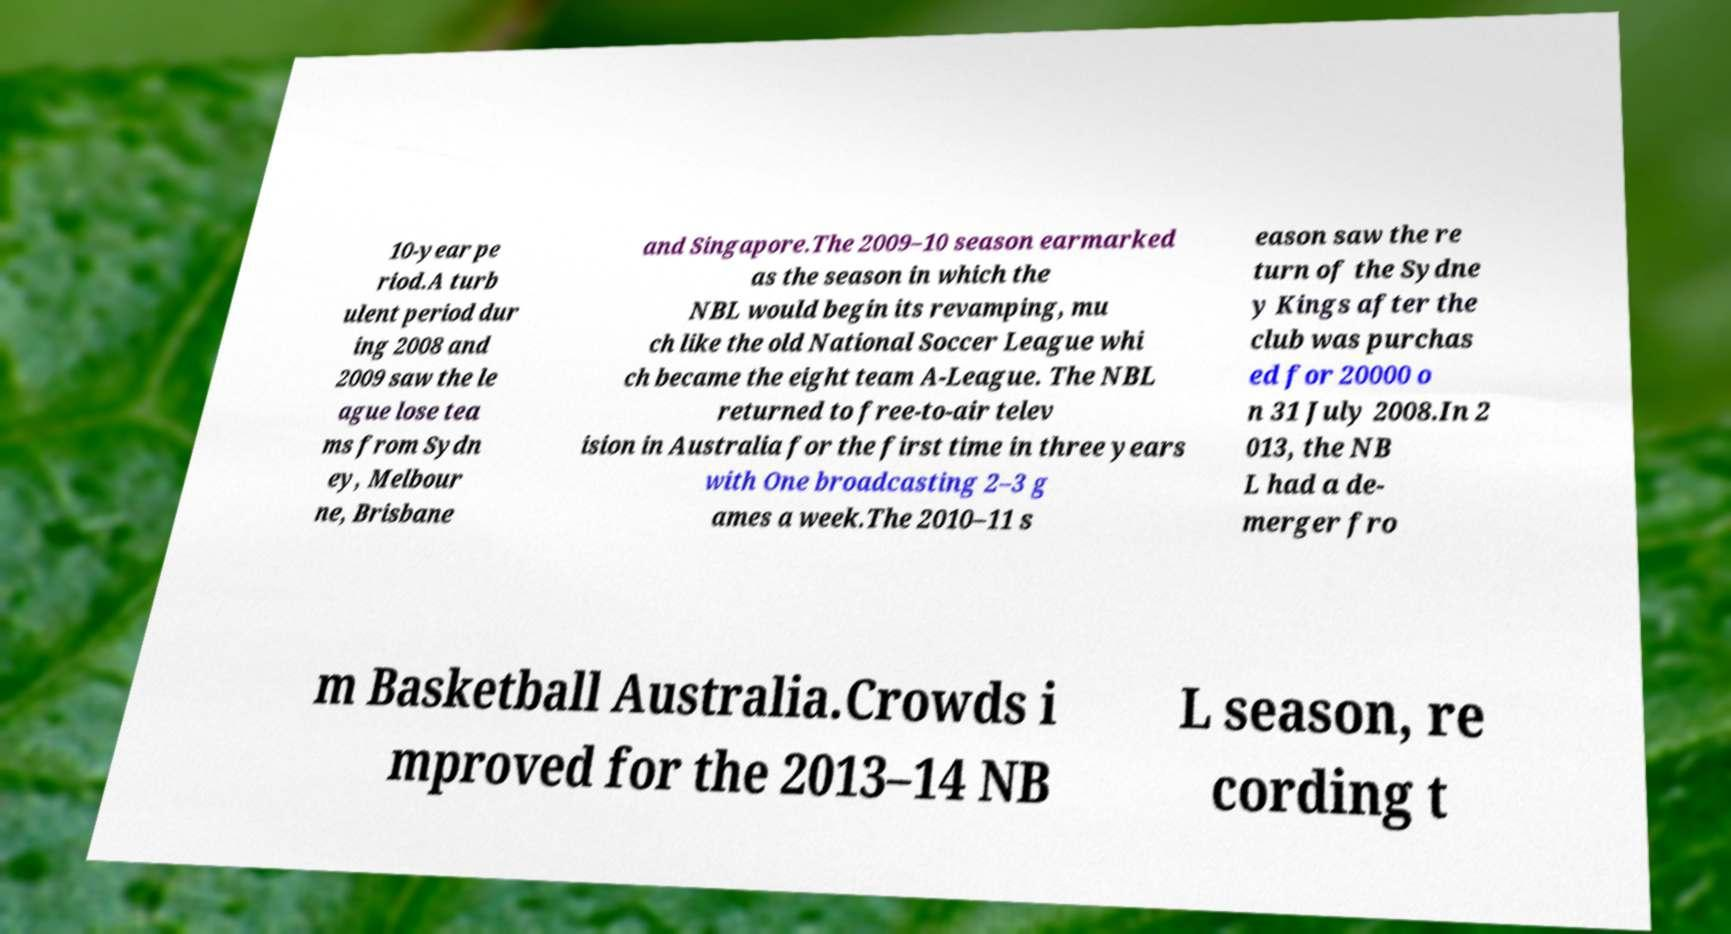There's text embedded in this image that I need extracted. Can you transcribe it verbatim? 10-year pe riod.A turb ulent period dur ing 2008 and 2009 saw the le ague lose tea ms from Sydn ey, Melbour ne, Brisbane and Singapore.The 2009–10 season earmarked as the season in which the NBL would begin its revamping, mu ch like the old National Soccer League whi ch became the eight team A-League. The NBL returned to free-to-air telev ision in Australia for the first time in three years with One broadcasting 2–3 g ames a week.The 2010–11 s eason saw the re turn of the Sydne y Kings after the club was purchas ed for 20000 o n 31 July 2008.In 2 013, the NB L had a de- merger fro m Basketball Australia.Crowds i mproved for the 2013–14 NB L season, re cording t 